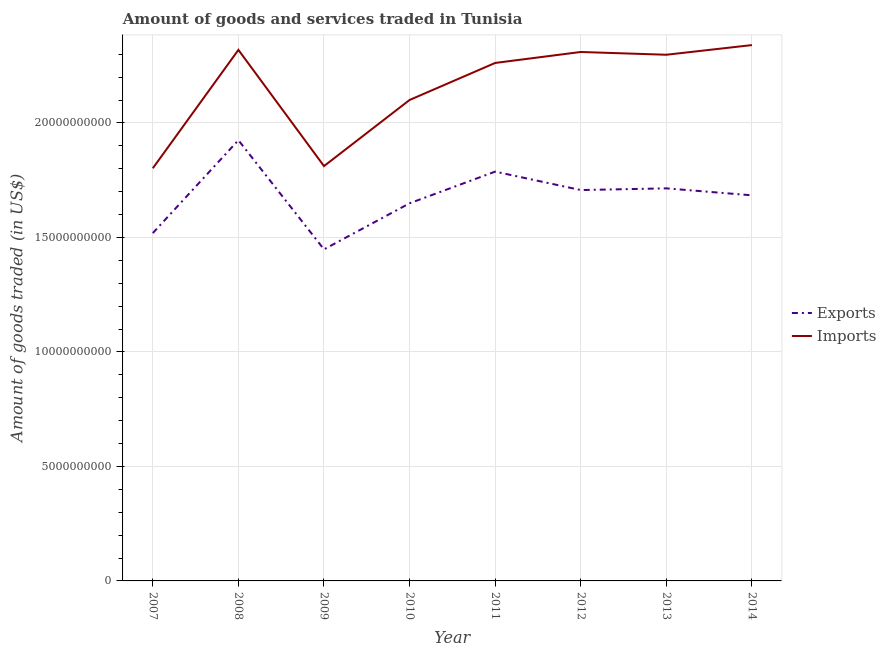What is the amount of goods imported in 2014?
Your answer should be very brief. 2.34e+1. Across all years, what is the maximum amount of goods exported?
Your answer should be compact. 1.92e+1. Across all years, what is the minimum amount of goods exported?
Your answer should be compact. 1.45e+1. In which year was the amount of goods exported maximum?
Keep it short and to the point. 2008. What is the total amount of goods imported in the graph?
Provide a short and direct response. 1.72e+11. What is the difference between the amount of goods exported in 2008 and that in 2009?
Offer a very short reply. 4.77e+09. What is the difference between the amount of goods exported in 2010 and the amount of goods imported in 2007?
Give a very brief answer. -1.53e+09. What is the average amount of goods exported per year?
Your answer should be compact. 1.68e+1. In the year 2008, what is the difference between the amount of goods imported and amount of goods exported?
Your response must be concise. 3.95e+09. In how many years, is the amount of goods imported greater than 7000000000 US$?
Make the answer very short. 8. What is the ratio of the amount of goods exported in 2007 to that in 2011?
Keep it short and to the point. 0.85. Is the difference between the amount of goods imported in 2010 and 2011 greater than the difference between the amount of goods exported in 2010 and 2011?
Make the answer very short. No. What is the difference between the highest and the second highest amount of goods imported?
Keep it short and to the point. 2.09e+08. What is the difference between the highest and the lowest amount of goods imported?
Provide a short and direct response. 5.38e+09. Is the sum of the amount of goods imported in 2010 and 2013 greater than the maximum amount of goods exported across all years?
Your answer should be very brief. Yes. Does the amount of goods imported monotonically increase over the years?
Provide a succinct answer. No. Is the amount of goods imported strictly greater than the amount of goods exported over the years?
Provide a short and direct response. Yes. Does the graph contain any zero values?
Ensure brevity in your answer.  No. How are the legend labels stacked?
Offer a very short reply. Vertical. What is the title of the graph?
Give a very brief answer. Amount of goods and services traded in Tunisia. Does "GDP at market prices" appear as one of the legend labels in the graph?
Provide a succinct answer. No. What is the label or title of the X-axis?
Ensure brevity in your answer.  Year. What is the label or title of the Y-axis?
Ensure brevity in your answer.  Amount of goods traded (in US$). What is the Amount of goods traded (in US$) in Exports in 2007?
Offer a terse response. 1.52e+1. What is the Amount of goods traded (in US$) of Imports in 2007?
Your response must be concise. 1.80e+1. What is the Amount of goods traded (in US$) in Exports in 2008?
Your answer should be very brief. 1.92e+1. What is the Amount of goods traded (in US$) of Imports in 2008?
Offer a very short reply. 2.32e+1. What is the Amount of goods traded (in US$) of Exports in 2009?
Make the answer very short. 1.45e+1. What is the Amount of goods traded (in US$) in Imports in 2009?
Offer a very short reply. 1.81e+1. What is the Amount of goods traded (in US$) in Exports in 2010?
Ensure brevity in your answer.  1.65e+1. What is the Amount of goods traded (in US$) in Imports in 2010?
Your response must be concise. 2.10e+1. What is the Amount of goods traded (in US$) in Exports in 2011?
Make the answer very short. 1.79e+1. What is the Amount of goods traded (in US$) in Imports in 2011?
Ensure brevity in your answer.  2.26e+1. What is the Amount of goods traded (in US$) of Exports in 2012?
Make the answer very short. 1.71e+1. What is the Amount of goods traded (in US$) of Imports in 2012?
Make the answer very short. 2.31e+1. What is the Amount of goods traded (in US$) in Exports in 2013?
Provide a succinct answer. 1.71e+1. What is the Amount of goods traded (in US$) of Imports in 2013?
Offer a very short reply. 2.30e+1. What is the Amount of goods traded (in US$) of Exports in 2014?
Provide a short and direct response. 1.68e+1. What is the Amount of goods traded (in US$) in Imports in 2014?
Ensure brevity in your answer.  2.34e+1. Across all years, what is the maximum Amount of goods traded (in US$) of Exports?
Ensure brevity in your answer.  1.92e+1. Across all years, what is the maximum Amount of goods traded (in US$) in Imports?
Provide a succinct answer. 2.34e+1. Across all years, what is the minimum Amount of goods traded (in US$) in Exports?
Give a very brief answer. 1.45e+1. Across all years, what is the minimum Amount of goods traded (in US$) in Imports?
Provide a succinct answer. 1.80e+1. What is the total Amount of goods traded (in US$) in Exports in the graph?
Keep it short and to the point. 1.34e+11. What is the total Amount of goods traded (in US$) of Imports in the graph?
Keep it short and to the point. 1.72e+11. What is the difference between the Amount of goods traded (in US$) in Exports in 2007 and that in 2008?
Your answer should be compact. -4.06e+09. What is the difference between the Amount of goods traded (in US$) of Imports in 2007 and that in 2008?
Ensure brevity in your answer.  -5.17e+09. What is the difference between the Amount of goods traded (in US$) of Exports in 2007 and that in 2009?
Offer a terse response. 7.11e+08. What is the difference between the Amount of goods traded (in US$) of Imports in 2007 and that in 2009?
Ensure brevity in your answer.  -9.39e+07. What is the difference between the Amount of goods traded (in US$) of Exports in 2007 and that in 2010?
Your answer should be very brief. -1.30e+09. What is the difference between the Amount of goods traded (in US$) of Imports in 2007 and that in 2010?
Your answer should be very brief. -2.98e+09. What is the difference between the Amount of goods traded (in US$) of Exports in 2007 and that in 2011?
Offer a terse response. -2.68e+09. What is the difference between the Amount of goods traded (in US$) in Imports in 2007 and that in 2011?
Offer a very short reply. -4.60e+09. What is the difference between the Amount of goods traded (in US$) of Exports in 2007 and that in 2012?
Your response must be concise. -1.88e+09. What is the difference between the Amount of goods traded (in US$) of Imports in 2007 and that in 2012?
Offer a very short reply. -5.08e+09. What is the difference between the Amount of goods traded (in US$) of Exports in 2007 and that in 2013?
Provide a succinct answer. -1.95e+09. What is the difference between the Amount of goods traded (in US$) in Imports in 2007 and that in 2013?
Give a very brief answer. -4.96e+09. What is the difference between the Amount of goods traded (in US$) in Exports in 2007 and that in 2014?
Keep it short and to the point. -1.65e+09. What is the difference between the Amount of goods traded (in US$) of Imports in 2007 and that in 2014?
Offer a very short reply. -5.38e+09. What is the difference between the Amount of goods traded (in US$) of Exports in 2008 and that in 2009?
Your answer should be very brief. 4.77e+09. What is the difference between the Amount of goods traded (in US$) in Imports in 2008 and that in 2009?
Provide a short and direct response. 5.08e+09. What is the difference between the Amount of goods traded (in US$) in Exports in 2008 and that in 2010?
Make the answer very short. 2.76e+09. What is the difference between the Amount of goods traded (in US$) of Imports in 2008 and that in 2010?
Keep it short and to the point. 2.19e+09. What is the difference between the Amount of goods traded (in US$) in Exports in 2008 and that in 2011?
Make the answer very short. 1.37e+09. What is the difference between the Amount of goods traded (in US$) in Imports in 2008 and that in 2011?
Offer a very short reply. 5.71e+08. What is the difference between the Amount of goods traded (in US$) in Exports in 2008 and that in 2012?
Your answer should be very brief. 2.18e+09. What is the difference between the Amount of goods traded (in US$) of Imports in 2008 and that in 2012?
Keep it short and to the point. 9.18e+07. What is the difference between the Amount of goods traded (in US$) in Exports in 2008 and that in 2013?
Provide a short and direct response. 2.10e+09. What is the difference between the Amount of goods traded (in US$) in Imports in 2008 and that in 2013?
Your answer should be very brief. 2.13e+08. What is the difference between the Amount of goods traded (in US$) of Exports in 2008 and that in 2014?
Provide a succinct answer. 2.41e+09. What is the difference between the Amount of goods traded (in US$) of Imports in 2008 and that in 2014?
Offer a very short reply. -2.09e+08. What is the difference between the Amount of goods traded (in US$) in Exports in 2009 and that in 2010?
Provide a succinct answer. -2.01e+09. What is the difference between the Amount of goods traded (in US$) in Imports in 2009 and that in 2010?
Provide a short and direct response. -2.89e+09. What is the difference between the Amount of goods traded (in US$) in Exports in 2009 and that in 2011?
Provide a short and direct response. -3.39e+09. What is the difference between the Amount of goods traded (in US$) of Imports in 2009 and that in 2011?
Give a very brief answer. -4.51e+09. What is the difference between the Amount of goods traded (in US$) in Exports in 2009 and that in 2012?
Offer a very short reply. -2.59e+09. What is the difference between the Amount of goods traded (in US$) of Imports in 2009 and that in 2012?
Your answer should be compact. -4.98e+09. What is the difference between the Amount of goods traded (in US$) of Exports in 2009 and that in 2013?
Your answer should be compact. -2.66e+09. What is the difference between the Amount of goods traded (in US$) of Imports in 2009 and that in 2013?
Your answer should be very brief. -4.86e+09. What is the difference between the Amount of goods traded (in US$) in Exports in 2009 and that in 2014?
Keep it short and to the point. -2.36e+09. What is the difference between the Amount of goods traded (in US$) of Imports in 2009 and that in 2014?
Your response must be concise. -5.29e+09. What is the difference between the Amount of goods traded (in US$) of Exports in 2010 and that in 2011?
Keep it short and to the point. -1.38e+09. What is the difference between the Amount of goods traded (in US$) in Imports in 2010 and that in 2011?
Give a very brief answer. -1.62e+09. What is the difference between the Amount of goods traded (in US$) of Exports in 2010 and that in 2012?
Your answer should be compact. -5.78e+08. What is the difference between the Amount of goods traded (in US$) of Imports in 2010 and that in 2012?
Offer a very short reply. -2.10e+09. What is the difference between the Amount of goods traded (in US$) in Exports in 2010 and that in 2013?
Your answer should be compact. -6.52e+08. What is the difference between the Amount of goods traded (in US$) of Imports in 2010 and that in 2013?
Provide a short and direct response. -1.98e+09. What is the difference between the Amount of goods traded (in US$) of Exports in 2010 and that in 2014?
Ensure brevity in your answer.  -3.48e+08. What is the difference between the Amount of goods traded (in US$) of Imports in 2010 and that in 2014?
Keep it short and to the point. -2.40e+09. What is the difference between the Amount of goods traded (in US$) of Exports in 2011 and that in 2012?
Provide a succinct answer. 8.05e+08. What is the difference between the Amount of goods traded (in US$) in Imports in 2011 and that in 2012?
Offer a terse response. -4.79e+08. What is the difference between the Amount of goods traded (in US$) in Exports in 2011 and that in 2013?
Offer a very short reply. 7.31e+08. What is the difference between the Amount of goods traded (in US$) of Imports in 2011 and that in 2013?
Your answer should be very brief. -3.58e+08. What is the difference between the Amount of goods traded (in US$) in Exports in 2011 and that in 2014?
Offer a terse response. 1.04e+09. What is the difference between the Amount of goods traded (in US$) of Imports in 2011 and that in 2014?
Provide a short and direct response. -7.80e+08. What is the difference between the Amount of goods traded (in US$) in Exports in 2012 and that in 2013?
Your answer should be compact. -7.42e+07. What is the difference between the Amount of goods traded (in US$) in Imports in 2012 and that in 2013?
Provide a succinct answer. 1.21e+08. What is the difference between the Amount of goods traded (in US$) in Exports in 2012 and that in 2014?
Ensure brevity in your answer.  2.30e+08. What is the difference between the Amount of goods traded (in US$) in Imports in 2012 and that in 2014?
Keep it short and to the point. -3.01e+08. What is the difference between the Amount of goods traded (in US$) of Exports in 2013 and that in 2014?
Give a very brief answer. 3.04e+08. What is the difference between the Amount of goods traded (in US$) of Imports in 2013 and that in 2014?
Your response must be concise. -4.22e+08. What is the difference between the Amount of goods traded (in US$) in Exports in 2007 and the Amount of goods traded (in US$) in Imports in 2008?
Provide a succinct answer. -8.00e+09. What is the difference between the Amount of goods traded (in US$) of Exports in 2007 and the Amount of goods traded (in US$) of Imports in 2009?
Make the answer very short. -2.93e+09. What is the difference between the Amount of goods traded (in US$) of Exports in 2007 and the Amount of goods traded (in US$) of Imports in 2010?
Keep it short and to the point. -5.81e+09. What is the difference between the Amount of goods traded (in US$) in Exports in 2007 and the Amount of goods traded (in US$) in Imports in 2011?
Ensure brevity in your answer.  -7.43e+09. What is the difference between the Amount of goods traded (in US$) in Exports in 2007 and the Amount of goods traded (in US$) in Imports in 2012?
Your answer should be very brief. -7.91e+09. What is the difference between the Amount of goods traded (in US$) in Exports in 2007 and the Amount of goods traded (in US$) in Imports in 2013?
Provide a short and direct response. -7.79e+09. What is the difference between the Amount of goods traded (in US$) of Exports in 2007 and the Amount of goods traded (in US$) of Imports in 2014?
Your response must be concise. -8.21e+09. What is the difference between the Amount of goods traded (in US$) in Exports in 2008 and the Amount of goods traded (in US$) in Imports in 2009?
Keep it short and to the point. 1.13e+09. What is the difference between the Amount of goods traded (in US$) in Exports in 2008 and the Amount of goods traded (in US$) in Imports in 2010?
Offer a terse response. -1.76e+09. What is the difference between the Amount of goods traded (in US$) of Exports in 2008 and the Amount of goods traded (in US$) of Imports in 2011?
Offer a terse response. -3.37e+09. What is the difference between the Amount of goods traded (in US$) in Exports in 2008 and the Amount of goods traded (in US$) in Imports in 2012?
Your answer should be compact. -3.85e+09. What is the difference between the Amount of goods traded (in US$) in Exports in 2008 and the Amount of goods traded (in US$) in Imports in 2013?
Your answer should be very brief. -3.73e+09. What is the difference between the Amount of goods traded (in US$) in Exports in 2008 and the Amount of goods traded (in US$) in Imports in 2014?
Your response must be concise. -4.15e+09. What is the difference between the Amount of goods traded (in US$) in Exports in 2009 and the Amount of goods traded (in US$) in Imports in 2010?
Ensure brevity in your answer.  -6.52e+09. What is the difference between the Amount of goods traded (in US$) in Exports in 2009 and the Amount of goods traded (in US$) in Imports in 2011?
Make the answer very short. -8.14e+09. What is the difference between the Amount of goods traded (in US$) of Exports in 2009 and the Amount of goods traded (in US$) of Imports in 2012?
Provide a succinct answer. -8.62e+09. What is the difference between the Amount of goods traded (in US$) of Exports in 2009 and the Amount of goods traded (in US$) of Imports in 2013?
Your answer should be very brief. -8.50e+09. What is the difference between the Amount of goods traded (in US$) of Exports in 2009 and the Amount of goods traded (in US$) of Imports in 2014?
Keep it short and to the point. -8.92e+09. What is the difference between the Amount of goods traded (in US$) in Exports in 2010 and the Amount of goods traded (in US$) in Imports in 2011?
Provide a short and direct response. -6.13e+09. What is the difference between the Amount of goods traded (in US$) in Exports in 2010 and the Amount of goods traded (in US$) in Imports in 2012?
Offer a terse response. -6.61e+09. What is the difference between the Amount of goods traded (in US$) of Exports in 2010 and the Amount of goods traded (in US$) of Imports in 2013?
Offer a terse response. -6.49e+09. What is the difference between the Amount of goods traded (in US$) of Exports in 2010 and the Amount of goods traded (in US$) of Imports in 2014?
Give a very brief answer. -6.91e+09. What is the difference between the Amount of goods traded (in US$) in Exports in 2011 and the Amount of goods traded (in US$) in Imports in 2012?
Your response must be concise. -5.23e+09. What is the difference between the Amount of goods traded (in US$) in Exports in 2011 and the Amount of goods traded (in US$) in Imports in 2013?
Provide a short and direct response. -5.10e+09. What is the difference between the Amount of goods traded (in US$) in Exports in 2011 and the Amount of goods traded (in US$) in Imports in 2014?
Offer a very short reply. -5.53e+09. What is the difference between the Amount of goods traded (in US$) in Exports in 2012 and the Amount of goods traded (in US$) in Imports in 2013?
Your response must be concise. -5.91e+09. What is the difference between the Amount of goods traded (in US$) in Exports in 2012 and the Amount of goods traded (in US$) in Imports in 2014?
Offer a terse response. -6.33e+09. What is the difference between the Amount of goods traded (in US$) in Exports in 2013 and the Amount of goods traded (in US$) in Imports in 2014?
Make the answer very short. -6.26e+09. What is the average Amount of goods traded (in US$) in Exports per year?
Give a very brief answer. 1.68e+1. What is the average Amount of goods traded (in US$) in Imports per year?
Offer a very short reply. 2.16e+1. In the year 2007, what is the difference between the Amount of goods traded (in US$) in Exports and Amount of goods traded (in US$) in Imports?
Give a very brief answer. -2.83e+09. In the year 2008, what is the difference between the Amount of goods traded (in US$) of Exports and Amount of goods traded (in US$) of Imports?
Make the answer very short. -3.95e+09. In the year 2009, what is the difference between the Amount of goods traded (in US$) in Exports and Amount of goods traded (in US$) in Imports?
Your answer should be very brief. -3.64e+09. In the year 2010, what is the difference between the Amount of goods traded (in US$) of Exports and Amount of goods traded (in US$) of Imports?
Offer a terse response. -4.51e+09. In the year 2011, what is the difference between the Amount of goods traded (in US$) in Exports and Amount of goods traded (in US$) in Imports?
Give a very brief answer. -4.75e+09. In the year 2012, what is the difference between the Amount of goods traded (in US$) in Exports and Amount of goods traded (in US$) in Imports?
Ensure brevity in your answer.  -6.03e+09. In the year 2013, what is the difference between the Amount of goods traded (in US$) in Exports and Amount of goods traded (in US$) in Imports?
Make the answer very short. -5.84e+09. In the year 2014, what is the difference between the Amount of goods traded (in US$) in Exports and Amount of goods traded (in US$) in Imports?
Offer a very short reply. -6.56e+09. What is the ratio of the Amount of goods traded (in US$) of Exports in 2007 to that in 2008?
Offer a terse response. 0.79. What is the ratio of the Amount of goods traded (in US$) of Imports in 2007 to that in 2008?
Keep it short and to the point. 0.78. What is the ratio of the Amount of goods traded (in US$) in Exports in 2007 to that in 2009?
Keep it short and to the point. 1.05. What is the ratio of the Amount of goods traded (in US$) of Exports in 2007 to that in 2010?
Your answer should be compact. 0.92. What is the ratio of the Amount of goods traded (in US$) in Imports in 2007 to that in 2010?
Provide a short and direct response. 0.86. What is the ratio of the Amount of goods traded (in US$) of Exports in 2007 to that in 2011?
Give a very brief answer. 0.85. What is the ratio of the Amount of goods traded (in US$) of Imports in 2007 to that in 2011?
Keep it short and to the point. 0.8. What is the ratio of the Amount of goods traded (in US$) in Exports in 2007 to that in 2012?
Offer a terse response. 0.89. What is the ratio of the Amount of goods traded (in US$) of Imports in 2007 to that in 2012?
Keep it short and to the point. 0.78. What is the ratio of the Amount of goods traded (in US$) of Exports in 2007 to that in 2013?
Give a very brief answer. 0.89. What is the ratio of the Amount of goods traded (in US$) in Imports in 2007 to that in 2013?
Provide a succinct answer. 0.78. What is the ratio of the Amount of goods traded (in US$) in Exports in 2007 to that in 2014?
Provide a short and direct response. 0.9. What is the ratio of the Amount of goods traded (in US$) in Imports in 2007 to that in 2014?
Provide a short and direct response. 0.77. What is the ratio of the Amount of goods traded (in US$) of Exports in 2008 to that in 2009?
Ensure brevity in your answer.  1.33. What is the ratio of the Amount of goods traded (in US$) of Imports in 2008 to that in 2009?
Your answer should be compact. 1.28. What is the ratio of the Amount of goods traded (in US$) of Exports in 2008 to that in 2010?
Give a very brief answer. 1.17. What is the ratio of the Amount of goods traded (in US$) of Imports in 2008 to that in 2010?
Offer a very short reply. 1.1. What is the ratio of the Amount of goods traded (in US$) of Exports in 2008 to that in 2011?
Keep it short and to the point. 1.08. What is the ratio of the Amount of goods traded (in US$) in Imports in 2008 to that in 2011?
Provide a short and direct response. 1.03. What is the ratio of the Amount of goods traded (in US$) of Exports in 2008 to that in 2012?
Give a very brief answer. 1.13. What is the ratio of the Amount of goods traded (in US$) of Exports in 2008 to that in 2013?
Your answer should be compact. 1.12. What is the ratio of the Amount of goods traded (in US$) in Imports in 2008 to that in 2013?
Offer a terse response. 1.01. What is the ratio of the Amount of goods traded (in US$) of Imports in 2008 to that in 2014?
Your answer should be very brief. 0.99. What is the ratio of the Amount of goods traded (in US$) in Exports in 2009 to that in 2010?
Make the answer very short. 0.88. What is the ratio of the Amount of goods traded (in US$) of Imports in 2009 to that in 2010?
Provide a succinct answer. 0.86. What is the ratio of the Amount of goods traded (in US$) in Exports in 2009 to that in 2011?
Your answer should be very brief. 0.81. What is the ratio of the Amount of goods traded (in US$) in Imports in 2009 to that in 2011?
Your response must be concise. 0.8. What is the ratio of the Amount of goods traded (in US$) of Exports in 2009 to that in 2012?
Your answer should be compact. 0.85. What is the ratio of the Amount of goods traded (in US$) in Imports in 2009 to that in 2012?
Provide a succinct answer. 0.78. What is the ratio of the Amount of goods traded (in US$) in Exports in 2009 to that in 2013?
Provide a short and direct response. 0.84. What is the ratio of the Amount of goods traded (in US$) in Imports in 2009 to that in 2013?
Offer a very short reply. 0.79. What is the ratio of the Amount of goods traded (in US$) in Exports in 2009 to that in 2014?
Provide a short and direct response. 0.86. What is the ratio of the Amount of goods traded (in US$) of Imports in 2009 to that in 2014?
Offer a terse response. 0.77. What is the ratio of the Amount of goods traded (in US$) of Exports in 2010 to that in 2011?
Provide a succinct answer. 0.92. What is the ratio of the Amount of goods traded (in US$) in Imports in 2010 to that in 2011?
Make the answer very short. 0.93. What is the ratio of the Amount of goods traded (in US$) in Exports in 2010 to that in 2012?
Ensure brevity in your answer.  0.97. What is the ratio of the Amount of goods traded (in US$) of Imports in 2010 to that in 2012?
Your answer should be very brief. 0.91. What is the ratio of the Amount of goods traded (in US$) in Imports in 2010 to that in 2013?
Your answer should be compact. 0.91. What is the ratio of the Amount of goods traded (in US$) in Exports in 2010 to that in 2014?
Your answer should be very brief. 0.98. What is the ratio of the Amount of goods traded (in US$) in Imports in 2010 to that in 2014?
Your answer should be very brief. 0.9. What is the ratio of the Amount of goods traded (in US$) in Exports in 2011 to that in 2012?
Your response must be concise. 1.05. What is the ratio of the Amount of goods traded (in US$) in Imports in 2011 to that in 2012?
Provide a short and direct response. 0.98. What is the ratio of the Amount of goods traded (in US$) of Exports in 2011 to that in 2013?
Ensure brevity in your answer.  1.04. What is the ratio of the Amount of goods traded (in US$) in Imports in 2011 to that in 2013?
Give a very brief answer. 0.98. What is the ratio of the Amount of goods traded (in US$) in Exports in 2011 to that in 2014?
Provide a short and direct response. 1.06. What is the ratio of the Amount of goods traded (in US$) in Imports in 2011 to that in 2014?
Give a very brief answer. 0.97. What is the ratio of the Amount of goods traded (in US$) in Exports in 2012 to that in 2013?
Offer a terse response. 1. What is the ratio of the Amount of goods traded (in US$) in Exports in 2012 to that in 2014?
Ensure brevity in your answer.  1.01. What is the ratio of the Amount of goods traded (in US$) of Imports in 2012 to that in 2014?
Your answer should be compact. 0.99. What is the ratio of the Amount of goods traded (in US$) in Exports in 2013 to that in 2014?
Offer a terse response. 1.02. What is the ratio of the Amount of goods traded (in US$) of Imports in 2013 to that in 2014?
Give a very brief answer. 0.98. What is the difference between the highest and the second highest Amount of goods traded (in US$) in Exports?
Offer a very short reply. 1.37e+09. What is the difference between the highest and the second highest Amount of goods traded (in US$) of Imports?
Your response must be concise. 2.09e+08. What is the difference between the highest and the lowest Amount of goods traded (in US$) in Exports?
Your answer should be compact. 4.77e+09. What is the difference between the highest and the lowest Amount of goods traded (in US$) in Imports?
Your response must be concise. 5.38e+09. 